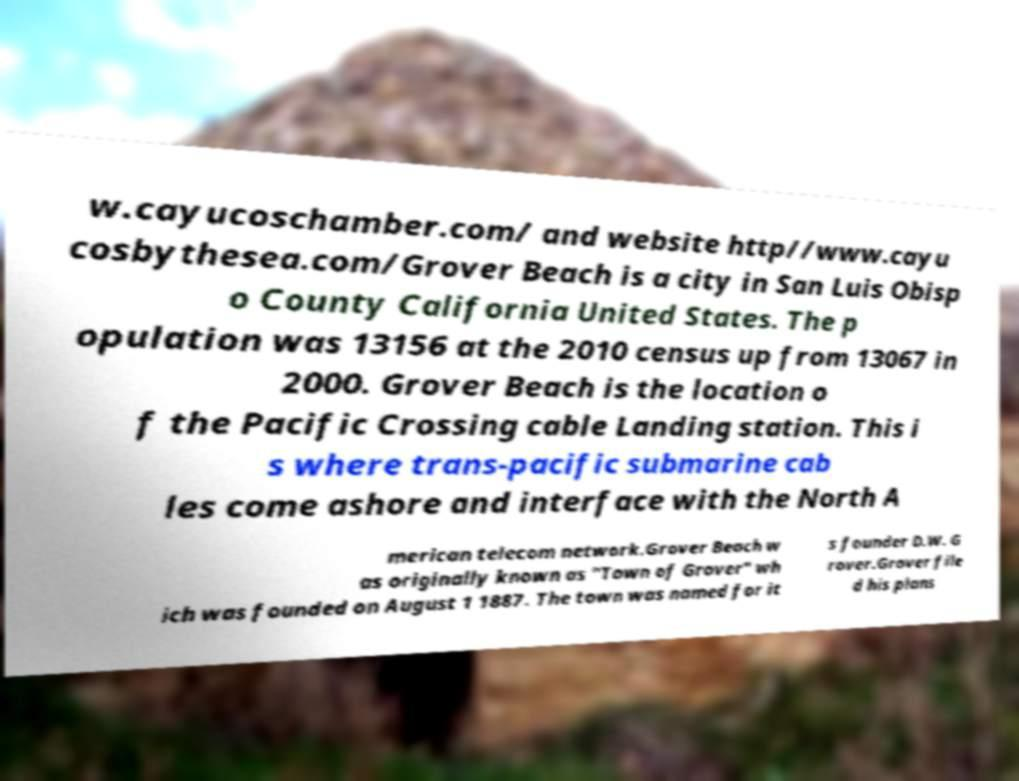Can you read and provide the text displayed in the image?This photo seems to have some interesting text. Can you extract and type it out for me? w.cayucoschamber.com/ and website http//www.cayu cosbythesea.com/Grover Beach is a city in San Luis Obisp o County California United States. The p opulation was 13156 at the 2010 census up from 13067 in 2000. Grover Beach is the location o f the Pacific Crossing cable Landing station. This i s where trans-pacific submarine cab les come ashore and interface with the North A merican telecom network.Grover Beach w as originally known as "Town of Grover" wh ich was founded on August 1 1887. The town was named for it s founder D.W. G rover.Grover file d his plans 